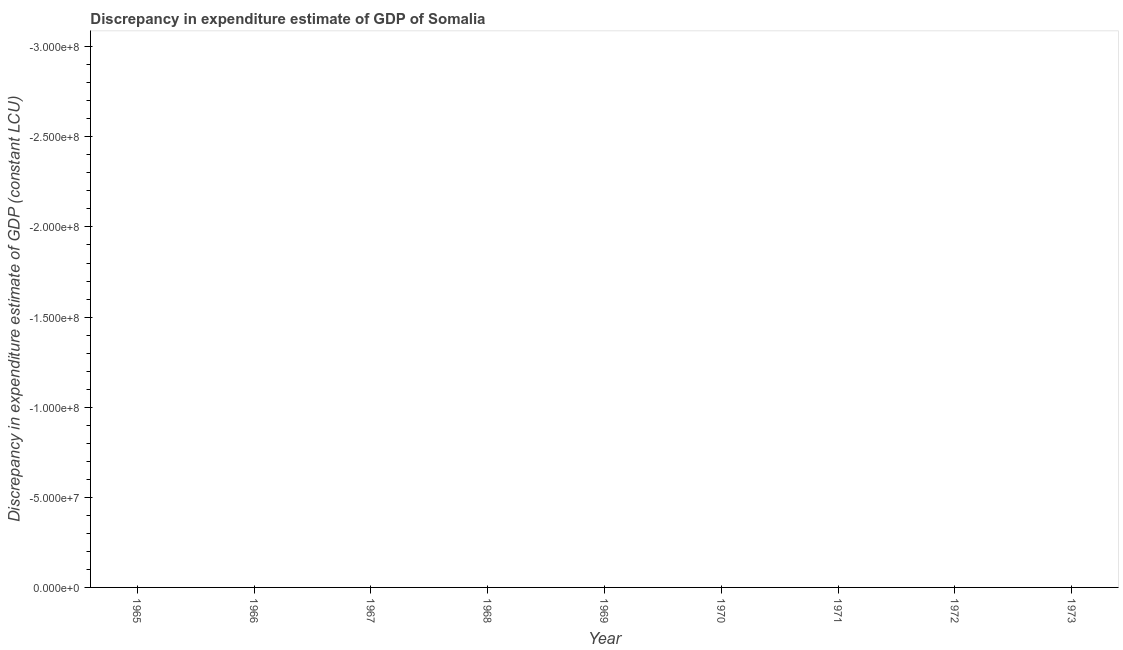Across all years, what is the minimum discrepancy in expenditure estimate of gdp?
Ensure brevity in your answer.  0. What is the sum of the discrepancy in expenditure estimate of gdp?
Ensure brevity in your answer.  0. What is the average discrepancy in expenditure estimate of gdp per year?
Your response must be concise. 0. What is the median discrepancy in expenditure estimate of gdp?
Offer a terse response. 0. In how many years, is the discrepancy in expenditure estimate of gdp greater than the average discrepancy in expenditure estimate of gdp taken over all years?
Provide a short and direct response. 0. How many lines are there?
Keep it short and to the point. 0. How many years are there in the graph?
Keep it short and to the point. 9. Are the values on the major ticks of Y-axis written in scientific E-notation?
Provide a short and direct response. Yes. Does the graph contain any zero values?
Make the answer very short. Yes. Does the graph contain grids?
Your answer should be very brief. No. What is the title of the graph?
Provide a short and direct response. Discrepancy in expenditure estimate of GDP of Somalia. What is the label or title of the Y-axis?
Offer a very short reply. Discrepancy in expenditure estimate of GDP (constant LCU). What is the Discrepancy in expenditure estimate of GDP (constant LCU) of 1965?
Your answer should be compact. 0. What is the Discrepancy in expenditure estimate of GDP (constant LCU) in 1967?
Provide a succinct answer. 0. What is the Discrepancy in expenditure estimate of GDP (constant LCU) in 1968?
Your answer should be compact. 0. What is the Discrepancy in expenditure estimate of GDP (constant LCU) in 1969?
Offer a terse response. 0. What is the Discrepancy in expenditure estimate of GDP (constant LCU) in 1971?
Your answer should be compact. 0. 